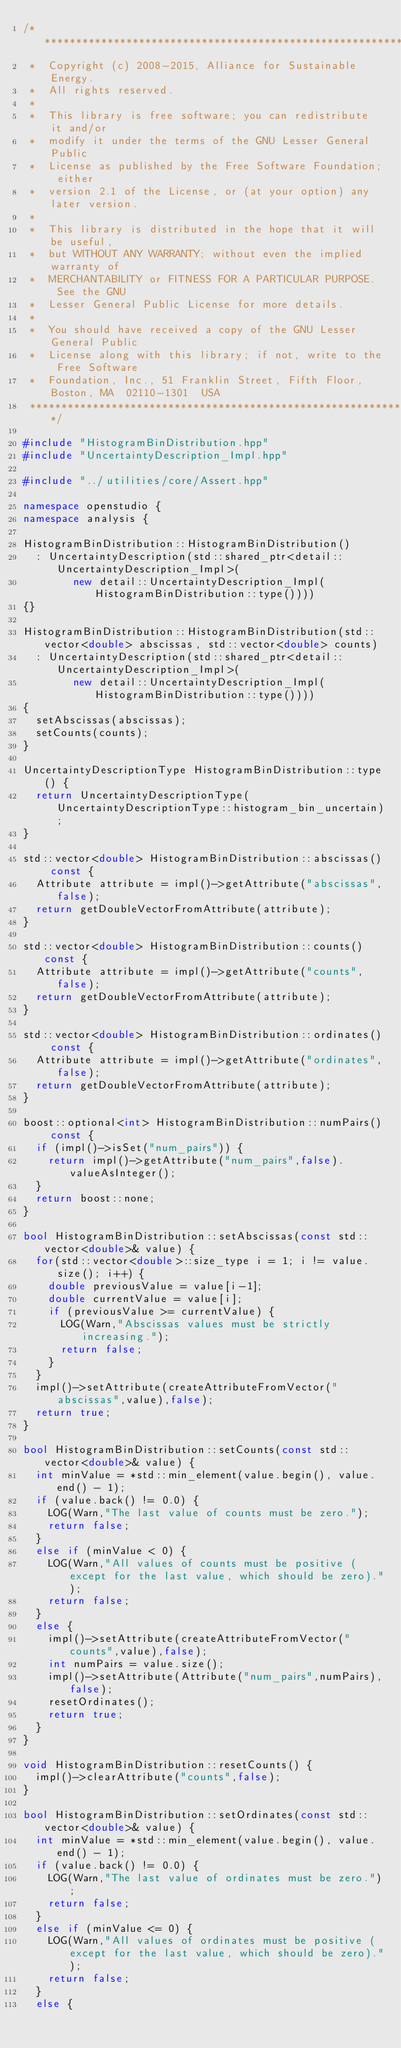<code> <loc_0><loc_0><loc_500><loc_500><_C++_>/**********************************************************************
 *  Copyright (c) 2008-2015, Alliance for Sustainable Energy.
 *  All rights reserved.
 *
 *  This library is free software; you can redistribute it and/or
 *  modify it under the terms of the GNU Lesser General Public
 *  License as published by the Free Software Foundation; either
 *  version 2.1 of the License, or (at your option) any later version.
 *
 *  This library is distributed in the hope that it will be useful,
 *  but WITHOUT ANY WARRANTY; without even the implied warranty of
 *  MERCHANTABILITY or FITNESS FOR A PARTICULAR PURPOSE.  See the GNU
 *  Lesser General Public License for more details.
 *
 *  You should have received a copy of the GNU Lesser General Public
 *  License along with this library; if not, write to the Free Software
 *  Foundation, Inc., 51 Franklin Street, Fifth Floor, Boston, MA  02110-1301  USA
 **********************************************************************/

#include "HistogramBinDistribution.hpp"
#include "UncertaintyDescription_Impl.hpp"

#include "../utilities/core/Assert.hpp"

namespace openstudio {
namespace analysis {

HistogramBinDistribution::HistogramBinDistribution() 
  : UncertaintyDescription(std::shared_ptr<detail::UncertaintyDescription_Impl>(
        new detail::UncertaintyDescription_Impl(HistogramBinDistribution::type())))
{}

HistogramBinDistribution::HistogramBinDistribution(std::vector<double> abscissas, std::vector<double> counts) 
  : UncertaintyDescription(std::shared_ptr<detail::UncertaintyDescription_Impl>(
        new detail::UncertaintyDescription_Impl(HistogramBinDistribution::type())))
{
  setAbscissas(abscissas);
  setCounts(counts);
}

UncertaintyDescriptionType HistogramBinDistribution::type() {
  return UncertaintyDescriptionType(UncertaintyDescriptionType::histogram_bin_uncertain);
}

std::vector<double> HistogramBinDistribution::abscissas() const {
  Attribute attribute = impl()->getAttribute("abscissas",false);
  return getDoubleVectorFromAttribute(attribute);
}

std::vector<double> HistogramBinDistribution::counts() const {
  Attribute attribute = impl()->getAttribute("counts",false);
  return getDoubleVectorFromAttribute(attribute);
}

std::vector<double> HistogramBinDistribution::ordinates() const {
  Attribute attribute = impl()->getAttribute("ordinates",false);
  return getDoubleVectorFromAttribute(attribute);
}

boost::optional<int> HistogramBinDistribution::numPairs() const {
  if (impl()->isSet("num_pairs")) {
    return impl()->getAttribute("num_pairs",false).valueAsInteger();
  }
  return boost::none;
}

bool HistogramBinDistribution::setAbscissas(const std::vector<double>& value) {
  for(std::vector<double>::size_type i = 1; i != value.size(); i++) {
    double previousValue = value[i-1];
    double currentValue = value[i];
    if (previousValue >= currentValue) {
      LOG(Warn,"Abscissas values must be strictly increasing.");
      return false;
    }
  }
  impl()->setAttribute(createAttributeFromVector("abscissas",value),false);
  return true;
}

bool HistogramBinDistribution::setCounts(const std::vector<double>& value) {
  int minValue = *std::min_element(value.begin(), value.end() - 1);
  if (value.back() != 0.0) {
    LOG(Warn,"The last value of counts must be zero.");
    return false;
  }
  else if (minValue < 0) {
    LOG(Warn,"All values of counts must be positive (except for the last value, which should be zero).");
    return false;
  }
  else {
    impl()->setAttribute(createAttributeFromVector("counts",value),false);
    int numPairs = value.size();
    impl()->setAttribute(Attribute("num_pairs",numPairs),false);
    resetOrdinates();
    return true;
  }
}

void HistogramBinDistribution::resetCounts() {
  impl()->clearAttribute("counts",false);
}

bool HistogramBinDistribution::setOrdinates(const std::vector<double>& value) {
  int minValue = *std::min_element(value.begin(), value.end() - 1);
  if (value.back() != 0.0) {
    LOG(Warn,"The last value of ordinates must be zero.");
    return false;
  }
  else if (minValue <= 0) {
    LOG(Warn,"All values of ordinates must be positive (except for the last value, which should be zero).");
    return false;
  }
  else {</code> 